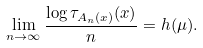<formula> <loc_0><loc_0><loc_500><loc_500>\lim _ { n \rightarrow \infty } \frac { \log \tau _ { A _ { n } ( x ) } ( x ) } { n } = h ( \mu ) .</formula> 